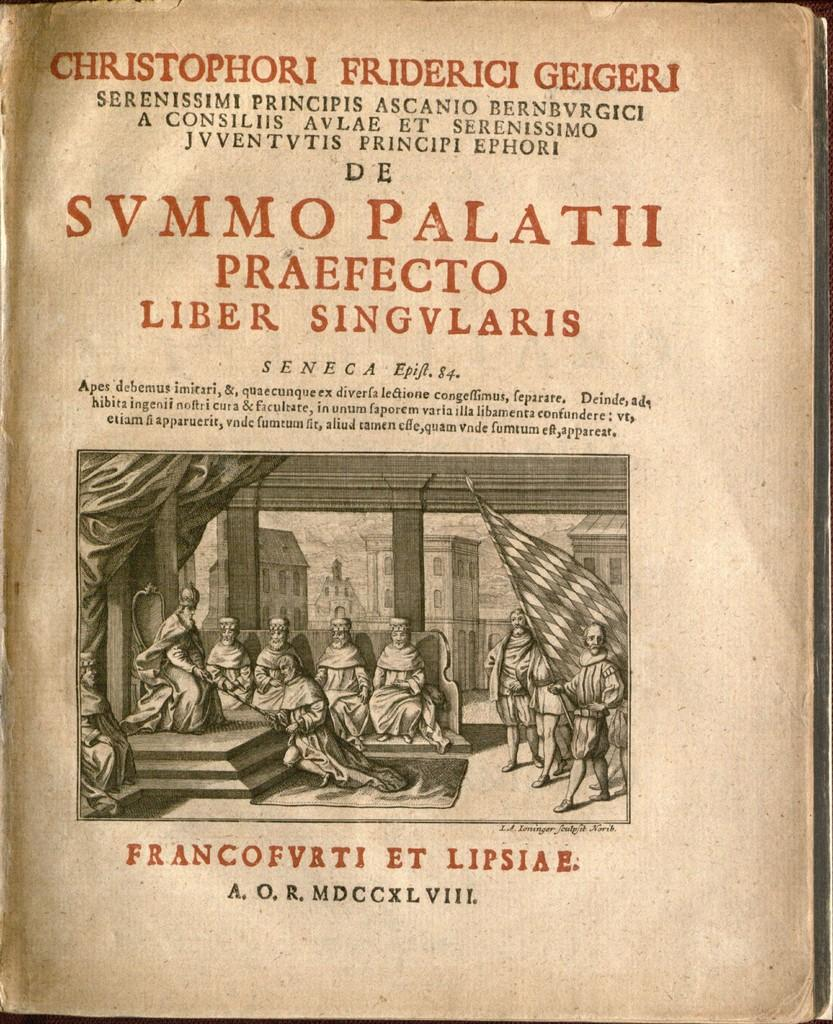<image>
Describe the image concisely. old book called svmmo palatti by frabcofvrti et 